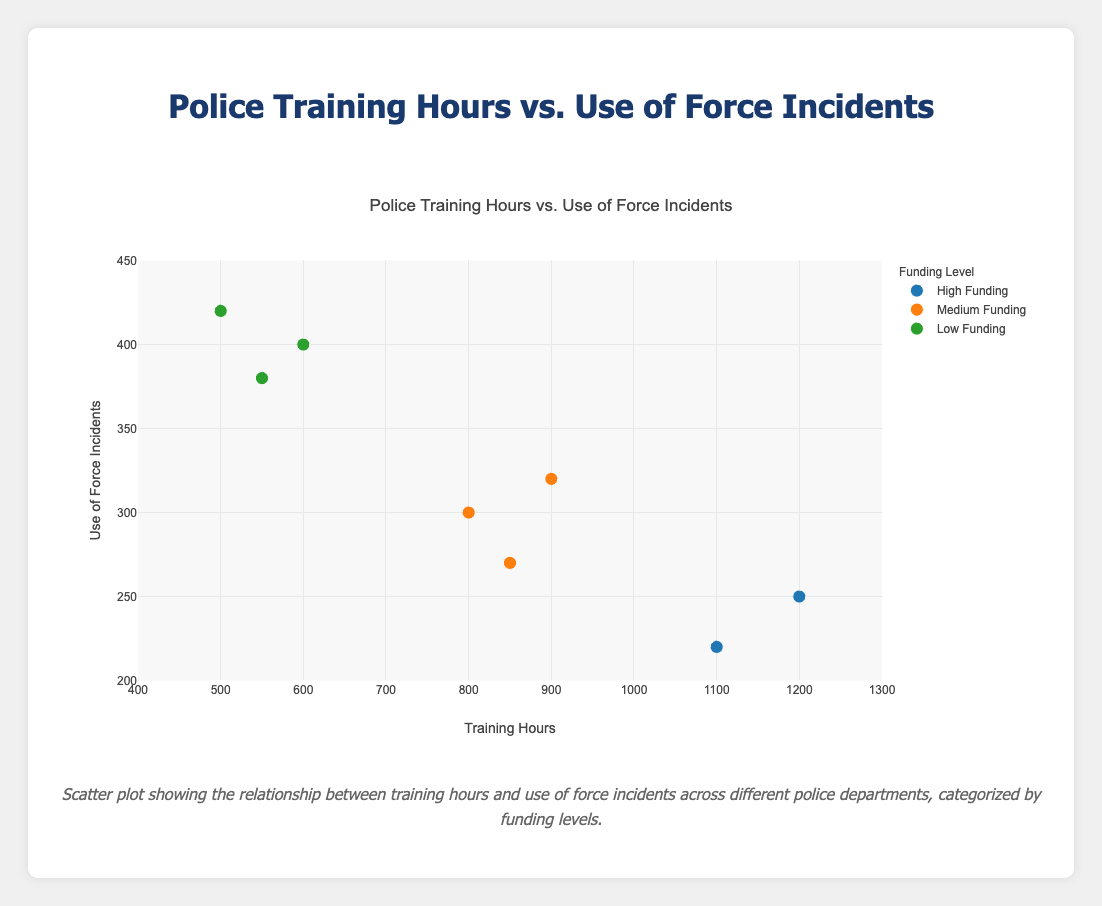What is the title of the scatter plot? The title of the scatter plot is usually found at the top center of the figure, stating the main focus of the data being displayed.
Answer: Police Training Hours vs. Use of Force Incidents How many data points are there for departments with high funding levels? Look at the legend and identify the 'High Funding' category, then count the corresponding markers on the plot.
Answer: 2 Which department has the highest number of use of force incidents? Analyze the y-axis and identify the highest data point, then refer to its label or refer to the hover information for that point.
Answer: Dallas PD What is the average number of training hours for departments with low funding levels? Identify the training hours of all departments with 'Low' funding and calculate the mean value. The departments are Philadelphia PD (600), San Antonio PD (550), and Dallas PD (500). The average is (600 + 550 + 500) / 3 = 550.
Answer: 550 Which funding level has the lowest average use of force incidents? Calculate the average use of force incidents for each funding category. High: (250 + 220) / 2 = 235, Medium: (300 + 270 + 320) / 3 = 296.67, Low: (400 + 380 + 420) / 3 = 400. The one with the smallest average is 'High'.
Answer: High How does the training hours correlate with the use of force incidents for medium-funded departments? Identify the data points for 'Medium' funding and observe the trend. Chicago PD, Houston PD, and Phoenix PD have training hours of 800, 850, and 900 respectively and use of force incidents of 300, 270, and 320. Generally, as training hours increase, incidents slightly decrease but are not very strongly correlated.
Answer: Slightly negative correlation Which department with medium funding levels has the highest use of force incidents? Look at the 'Medium Funding' data points and identify the department with the largest y-axis value.
Answer: Phoenix PD Is there a visible trend between training hours and use of force incidents for departments with low funding levels? Identify the data points for 'Low' funding. Philadelphia PD, San Antonio PD, and Dallas PD show that as training hours decrease from 600 to 500, use of force incidents increase from 400 to 420, suggesting a negative correlation.
Answer: Negative correlation 